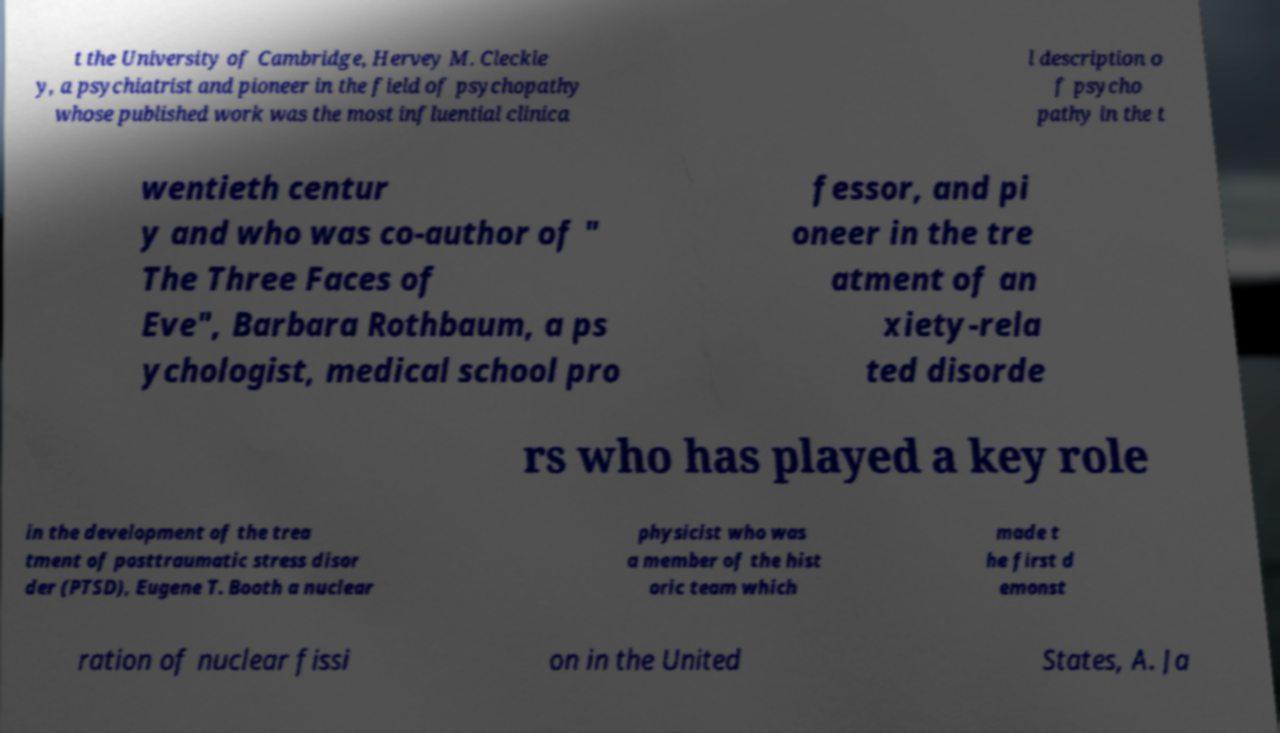I need the written content from this picture converted into text. Can you do that? t the University of Cambridge, Hervey M. Cleckle y, a psychiatrist and pioneer in the field of psychopathy whose published work was the most influential clinica l description o f psycho pathy in the t wentieth centur y and who was co-author of " The Three Faces of Eve", Barbara Rothbaum, a ps ychologist, medical school pro fessor, and pi oneer in the tre atment of an xiety-rela ted disorde rs who has played a key role in the development of the trea tment of posttraumatic stress disor der (PTSD), Eugene T. Booth a nuclear physicist who was a member of the hist oric team which made t he first d emonst ration of nuclear fissi on in the United States, A. Ja 